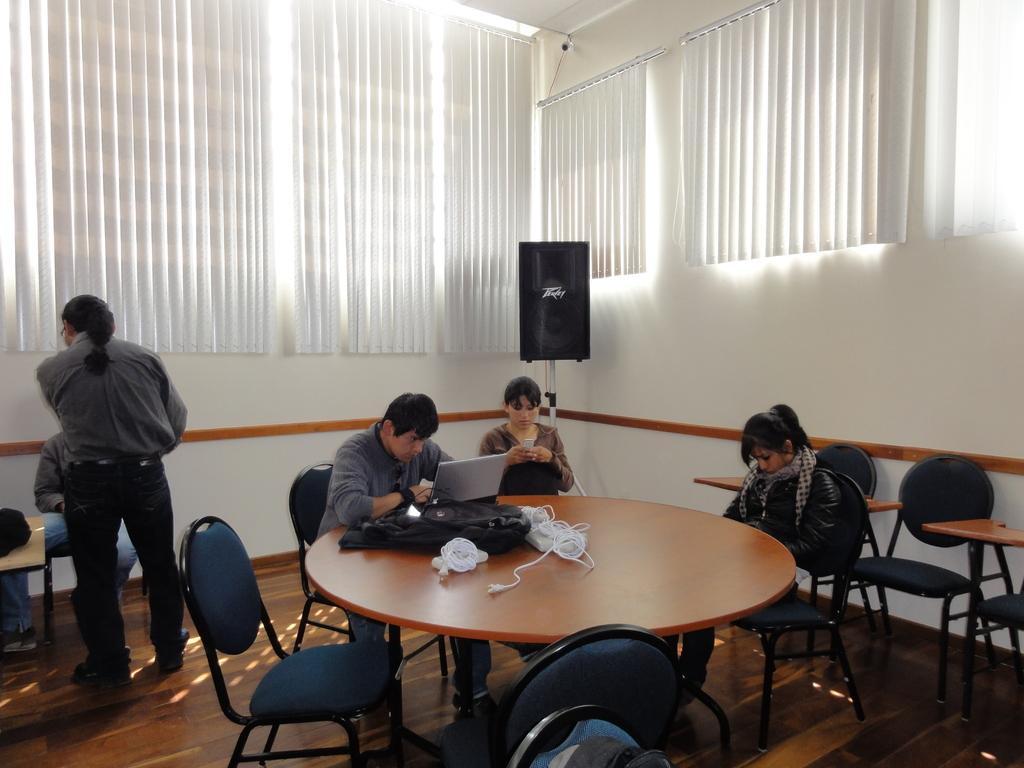How would you summarize this image in a sentence or two? In the middle of the image there is a table, On the table there is a bag and laptop. In the middle of the image there is a speaker and wall and there is a curtain. Bottom left side of the image a man is standing. 